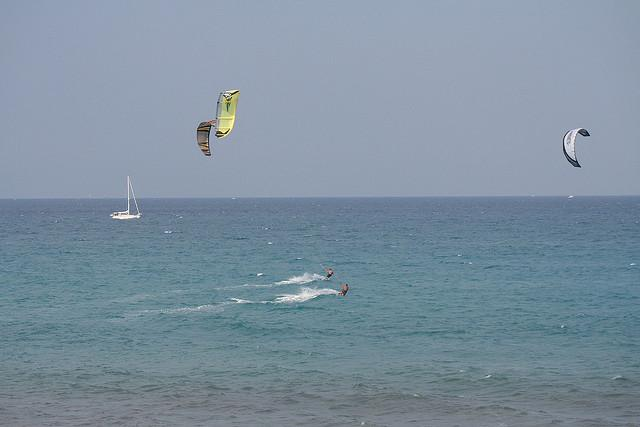What sport are the two people in the water participating in? Please explain your reasoning. para waterskiing. The people are para waterskiing. 